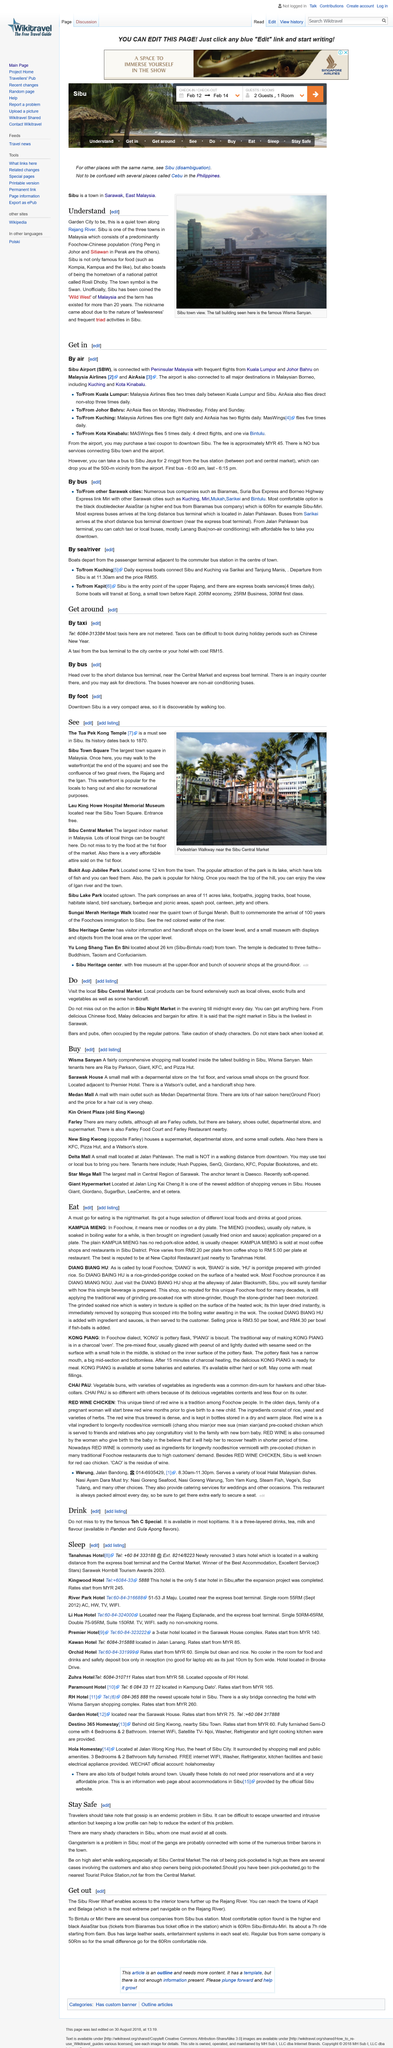Identify some key points in this picture. The New Capitol Restaurant near the Tanahmas Hotel is reputed to have the best Kampua Mieng. It is possible to obtain Malay delicacies from the Sibu Night Market. In the local dialect, "Kampua Mieng" means "mee or noodles on a dry plate." This term is used in Foochow to refer to a popular dish that consists of stir-fried noodles served on a sizzling hot plate. The term is derived from the Chinese word "粉碎麵" (fěnzuó miàn), which translates to "fine noodles." The Foochow community has adapted the term to suit their local cuisine and culture, which is why it has a different meaning in the local dialect. Bars and pubs are frequently visited by regular customers. The photograph depicts a pedestrian walkway near the Sibu Central Market. 